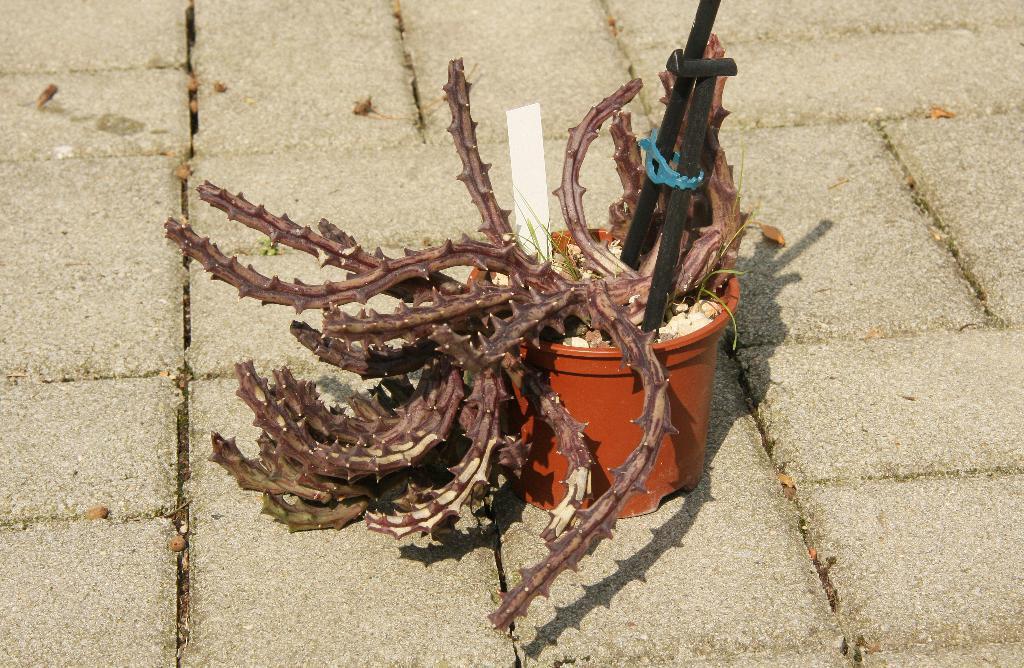Can you describe this image briefly? In this image we can see a plant and a plant pot and we can see two rods and the background is ground. 